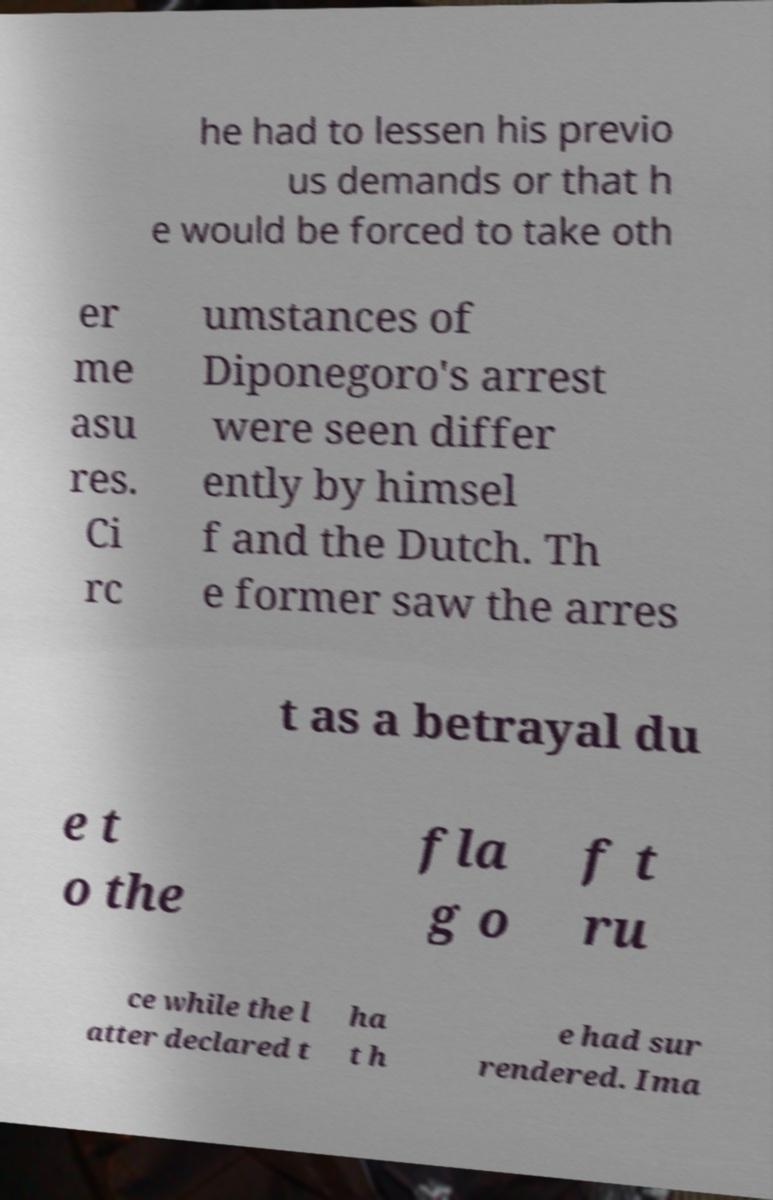Can you read and provide the text displayed in the image?This photo seems to have some interesting text. Can you extract and type it out for me? he had to lessen his previo us demands or that h e would be forced to take oth er me asu res. Ci rc umstances of Diponegoro's arrest were seen differ ently by himsel f and the Dutch. Th e former saw the arres t as a betrayal du e t o the fla g o f t ru ce while the l atter declared t ha t h e had sur rendered. Ima 